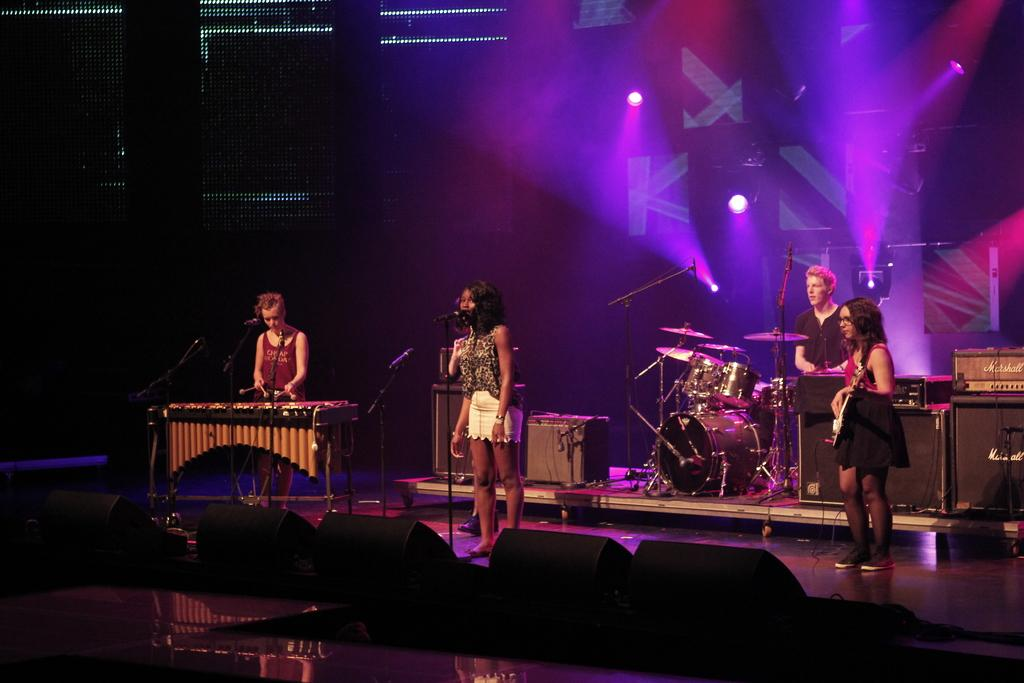How many people are in the image? There are four people in the image. What are the people doing in the image? The people are performing on a dais. What are the people using while performing? The people are using musical instruments. What device is present in the image for amplifying sound? A microphone is present in the image. What type of silk fabric is draped over the shelf in the image? There is no shelf or silk fabric present in the image. What role does the minister play in the performance in the image? There is no minister or performance involving a minister in the image. 